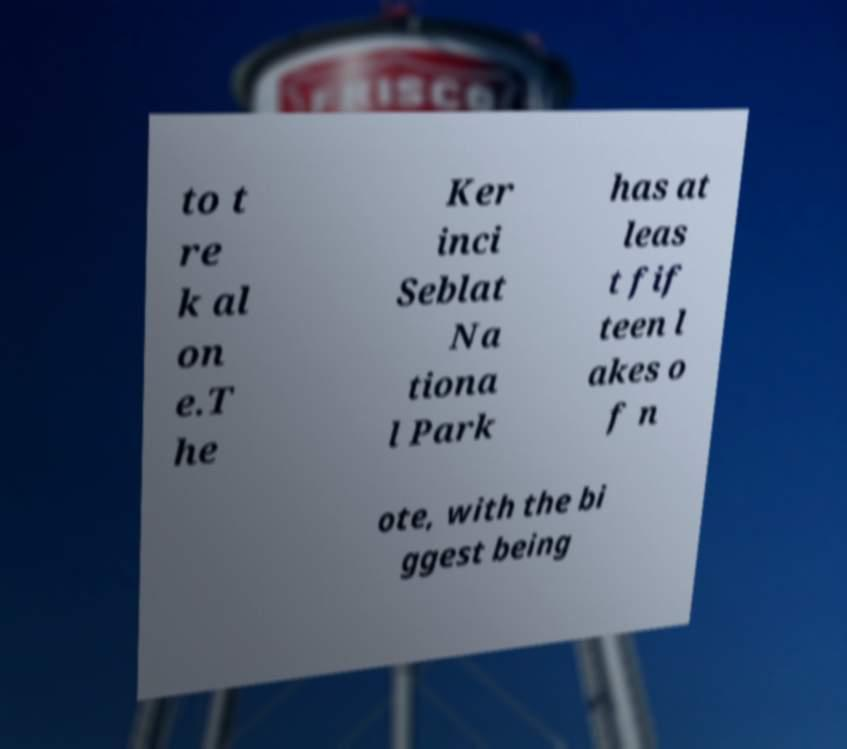I need the written content from this picture converted into text. Can you do that? to t re k al on e.T he Ker inci Seblat Na tiona l Park has at leas t fif teen l akes o f n ote, with the bi ggest being 